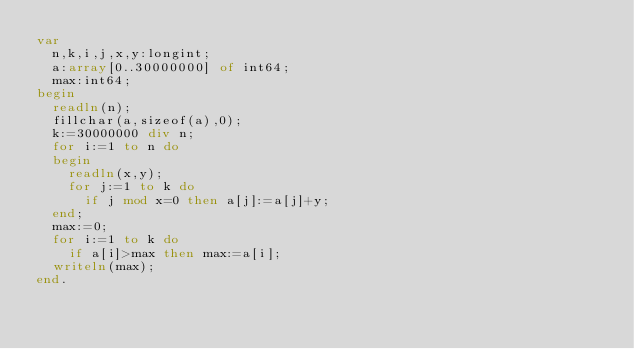<code> <loc_0><loc_0><loc_500><loc_500><_Pascal_>var
  n,k,i,j,x,y:longint;
  a:array[0..30000000] of int64;
  max:int64;
begin
  readln(n);
  fillchar(a,sizeof(a),0);
  k:=30000000 div n;
  for i:=1 to n do
  begin
    readln(x,y);
    for j:=1 to k do
      if j mod x=0 then a[j]:=a[j]+y;
  end;
  max:=0;
  for i:=1 to k do
    if a[i]>max then max:=a[i];
  writeln(max);
end.</code> 